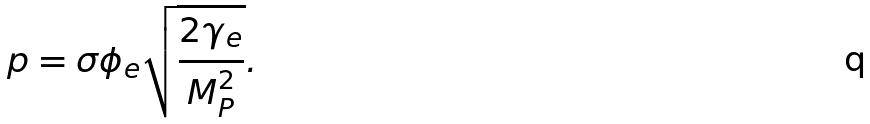Convert formula to latex. <formula><loc_0><loc_0><loc_500><loc_500>p = \sigma \phi _ { e } \sqrt { \frac { 2 \gamma _ { e } } { M _ { P } ^ { 2 } } } .</formula> 